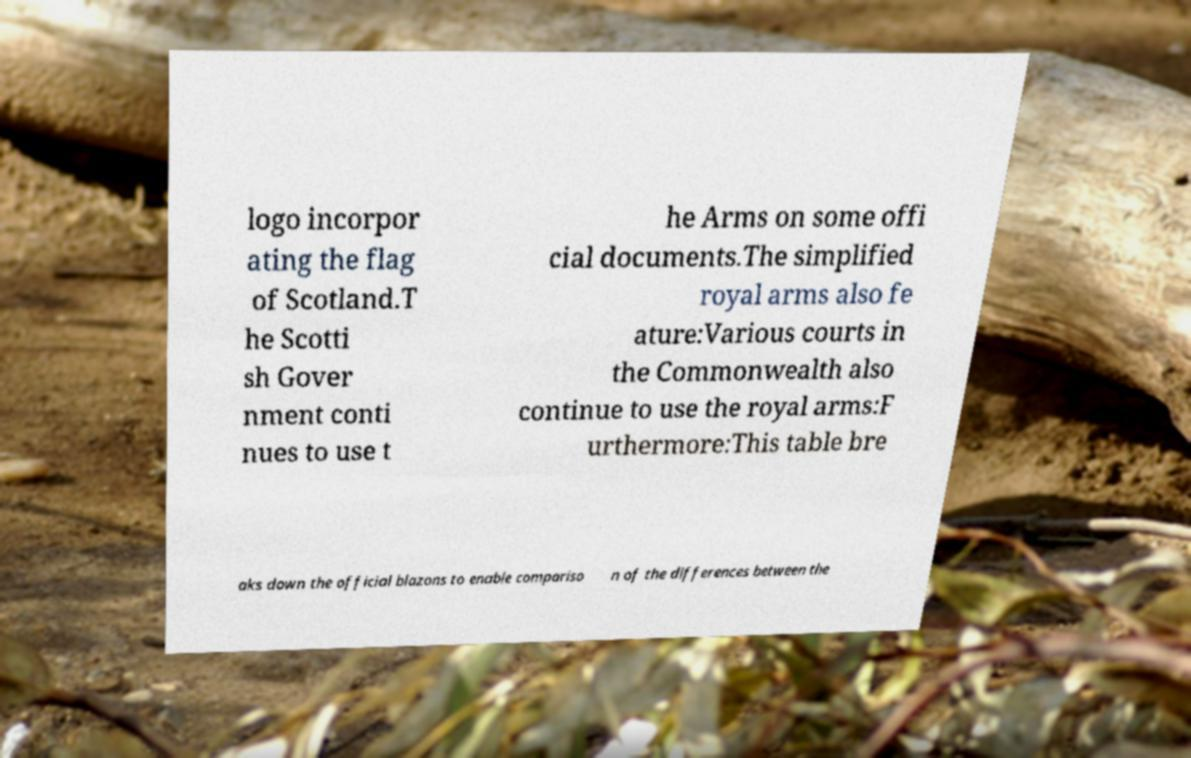Please identify and transcribe the text found in this image. logo incorpor ating the flag of Scotland.T he Scotti sh Gover nment conti nues to use t he Arms on some offi cial documents.The simplified royal arms also fe ature:Various courts in the Commonwealth also continue to use the royal arms:F urthermore:This table bre aks down the official blazons to enable compariso n of the differences between the 